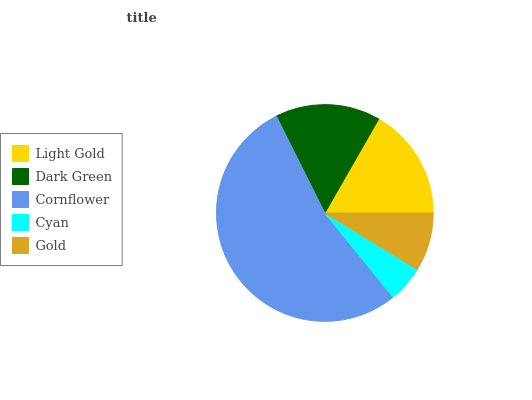Is Cyan the minimum?
Answer yes or no. Yes. Is Cornflower the maximum?
Answer yes or no. Yes. Is Dark Green the minimum?
Answer yes or no. No. Is Dark Green the maximum?
Answer yes or no. No. Is Light Gold greater than Dark Green?
Answer yes or no. Yes. Is Dark Green less than Light Gold?
Answer yes or no. Yes. Is Dark Green greater than Light Gold?
Answer yes or no. No. Is Light Gold less than Dark Green?
Answer yes or no. No. Is Dark Green the high median?
Answer yes or no. Yes. Is Dark Green the low median?
Answer yes or no. Yes. Is Cornflower the high median?
Answer yes or no. No. Is Light Gold the low median?
Answer yes or no. No. 